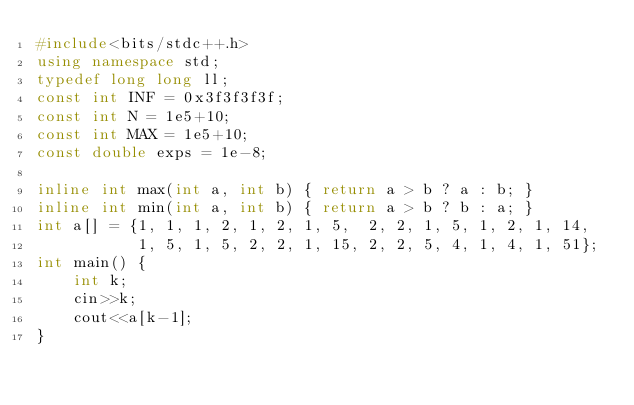Convert code to text. <code><loc_0><loc_0><loc_500><loc_500><_C++_>#include<bits/stdc++.h>
using namespace std;
typedef long long ll;
const int INF = 0x3f3f3f3f;
const int N = 1e5+10;
const int MAX = 1e5+10;
const double exps = 1e-8;

inline int max(int a, int b) { return a > b ? a : b; }
inline int min(int a, int b) { return a > b ? b : a; }
int a[] = {1, 1, 1, 2, 1, 2, 1, 5,  2, 2, 1, 5, 1, 2, 1, 14,
           1, 5, 1, 5, 2, 2, 1, 15, 2, 2, 5, 4, 1, 4, 1, 51}; 
int main() {
    int k;
    cin>>k;
    cout<<a[k-1];
}</code> 